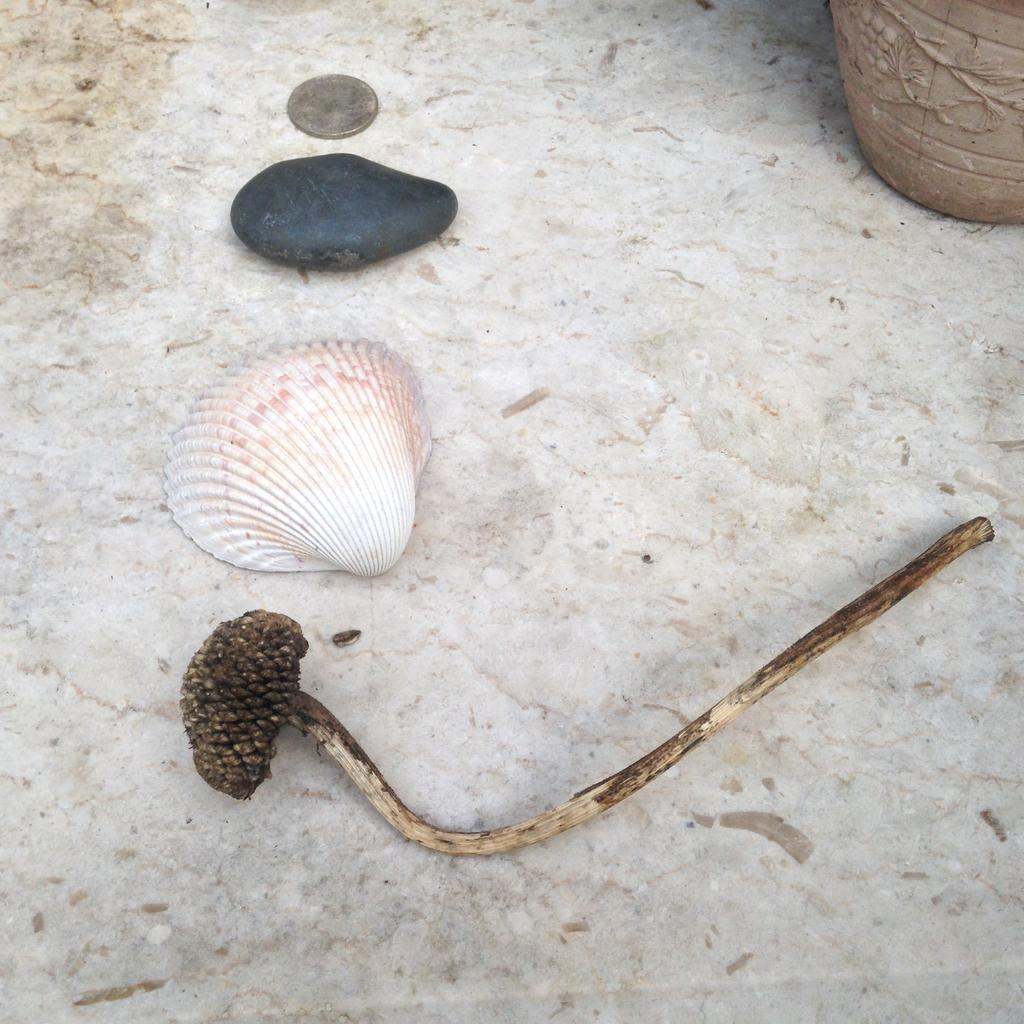What objects can be seen on the floor in the image? There is a coin, a pebble, and a shell on the floor in the image. What else is visible in the top right corner of the image? There is an object that appears to be a pot in the top right corner of the image. What type of tin can be seen in the image? There is no tin present in the image. Can you describe the animal that is interacting with the shell in the image? There are no animals present in the image; it only features the coin, pebble, shell, and pot. 